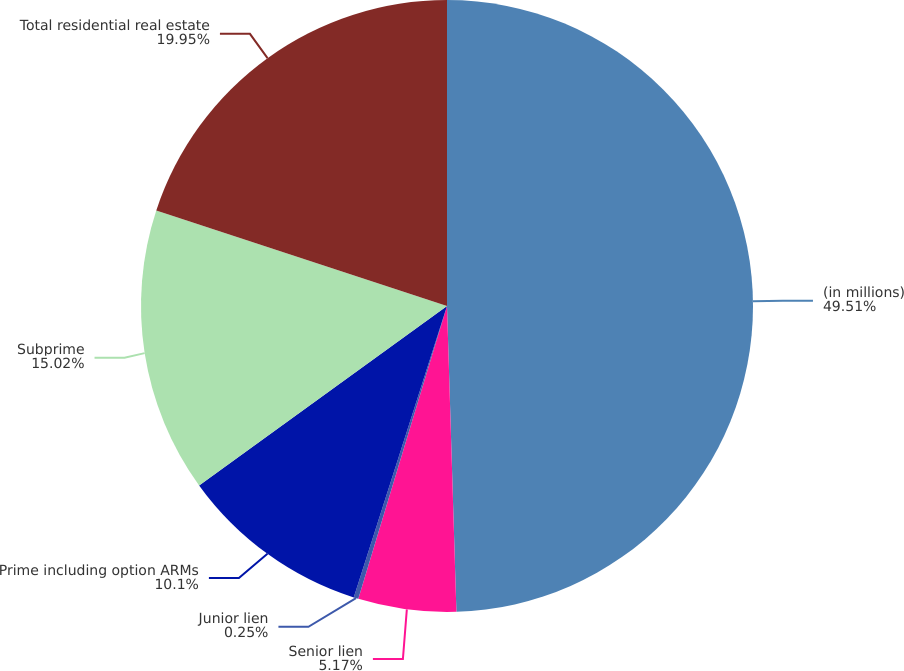<chart> <loc_0><loc_0><loc_500><loc_500><pie_chart><fcel>(in millions)<fcel>Senior lien<fcel>Junior lien<fcel>Prime including option ARMs<fcel>Subprime<fcel>Total residential real estate<nl><fcel>49.51%<fcel>5.17%<fcel>0.25%<fcel>10.1%<fcel>15.02%<fcel>19.95%<nl></chart> 